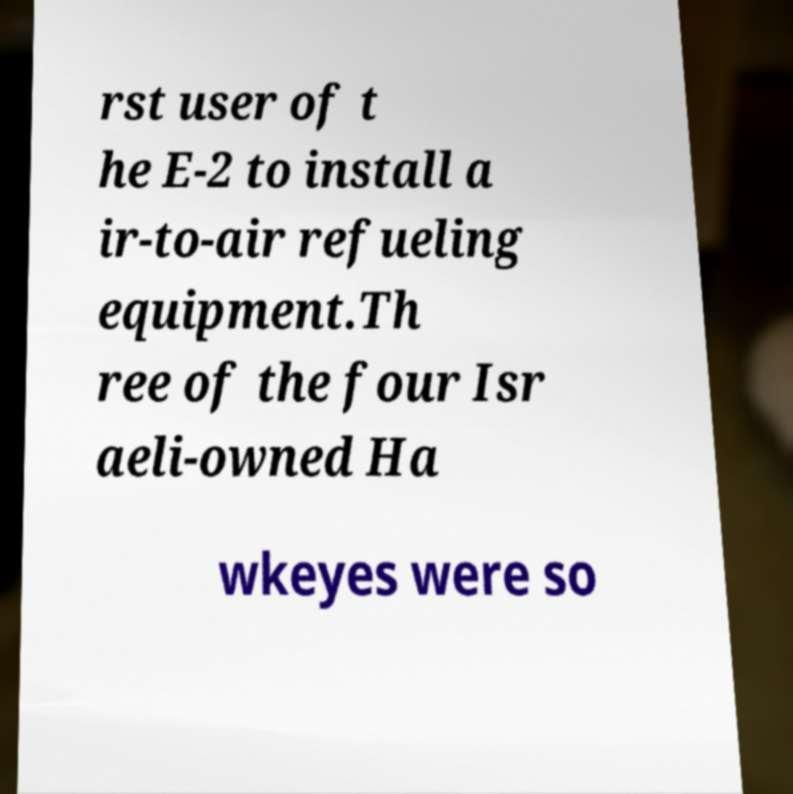Could you extract and type out the text from this image? rst user of t he E-2 to install a ir-to-air refueling equipment.Th ree of the four Isr aeli-owned Ha wkeyes were so 